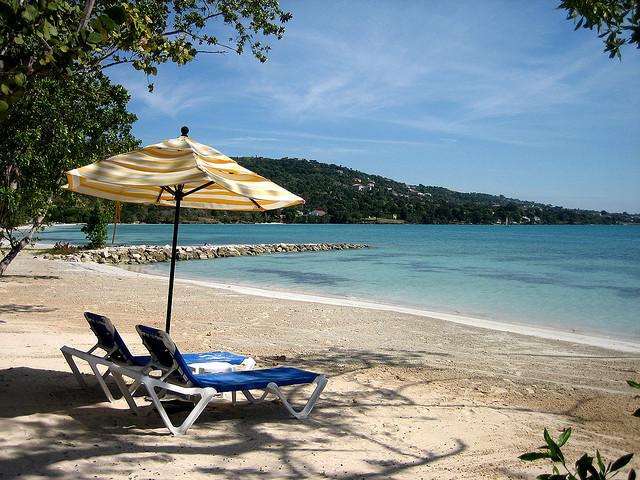Is this a vacation resort?
Quick response, please. Yes. What color are the loungers?
Answer briefly. Blue. Are there people in the water?
Concise answer only. No. 